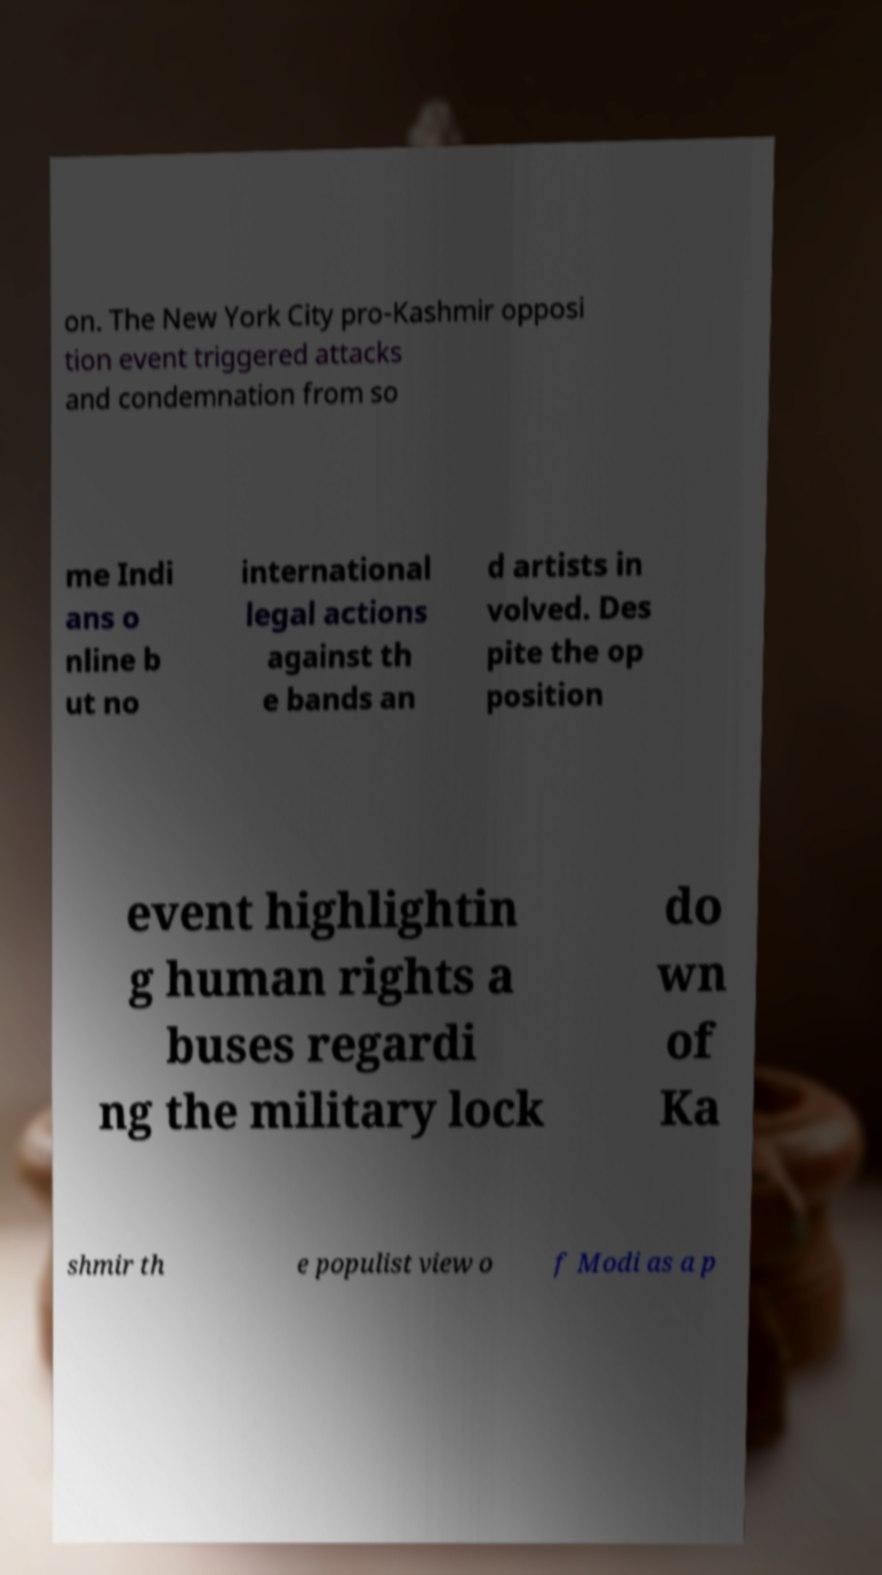Could you extract and type out the text from this image? on. The New York City pro-Kashmir opposi tion event triggered attacks and condemnation from so me Indi ans o nline b ut no international legal actions against th e bands an d artists in volved. Des pite the op position event highlightin g human rights a buses regardi ng the military lock do wn of Ka shmir th e populist view o f Modi as a p 